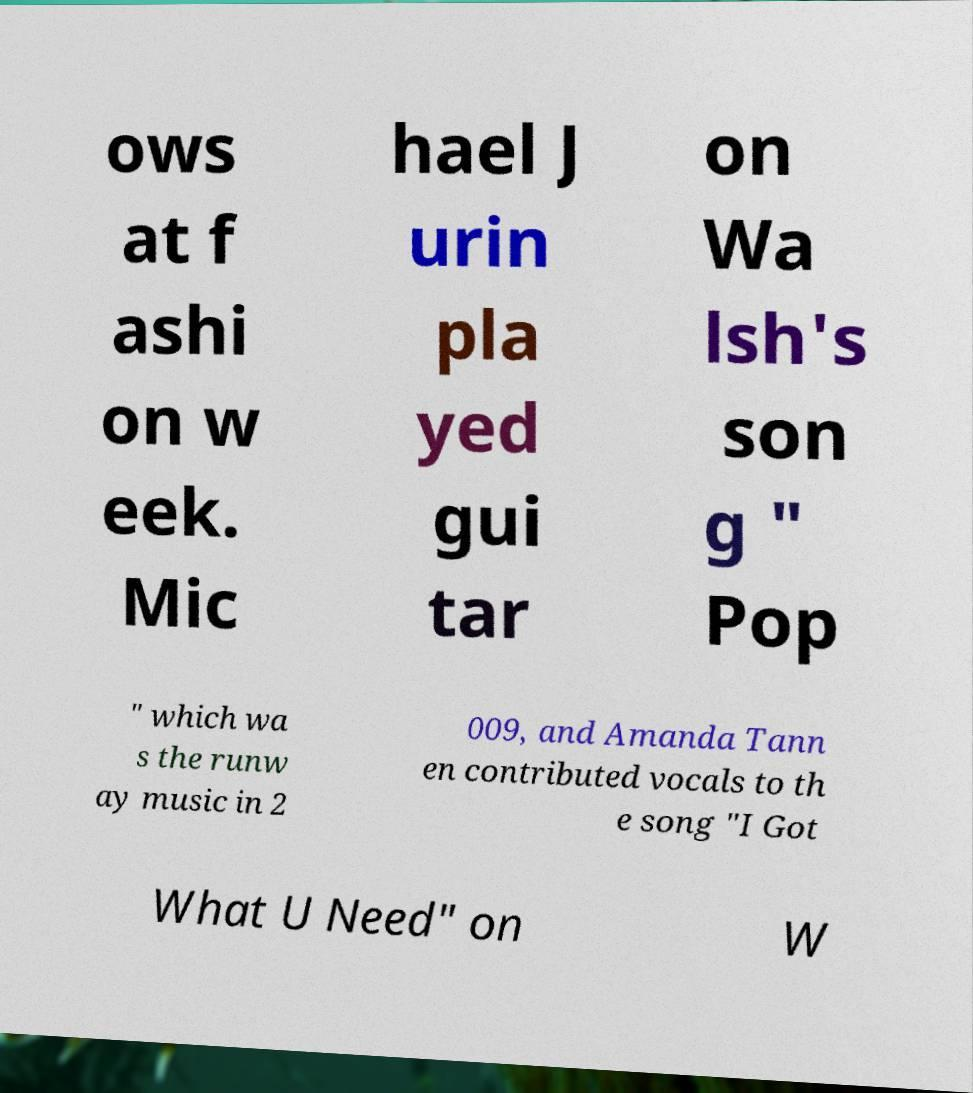I need the written content from this picture converted into text. Can you do that? ows at f ashi on w eek. Mic hael J urin pla yed gui tar on Wa lsh's son g " Pop " which wa s the runw ay music in 2 009, and Amanda Tann en contributed vocals to th e song "I Got What U Need" on W 